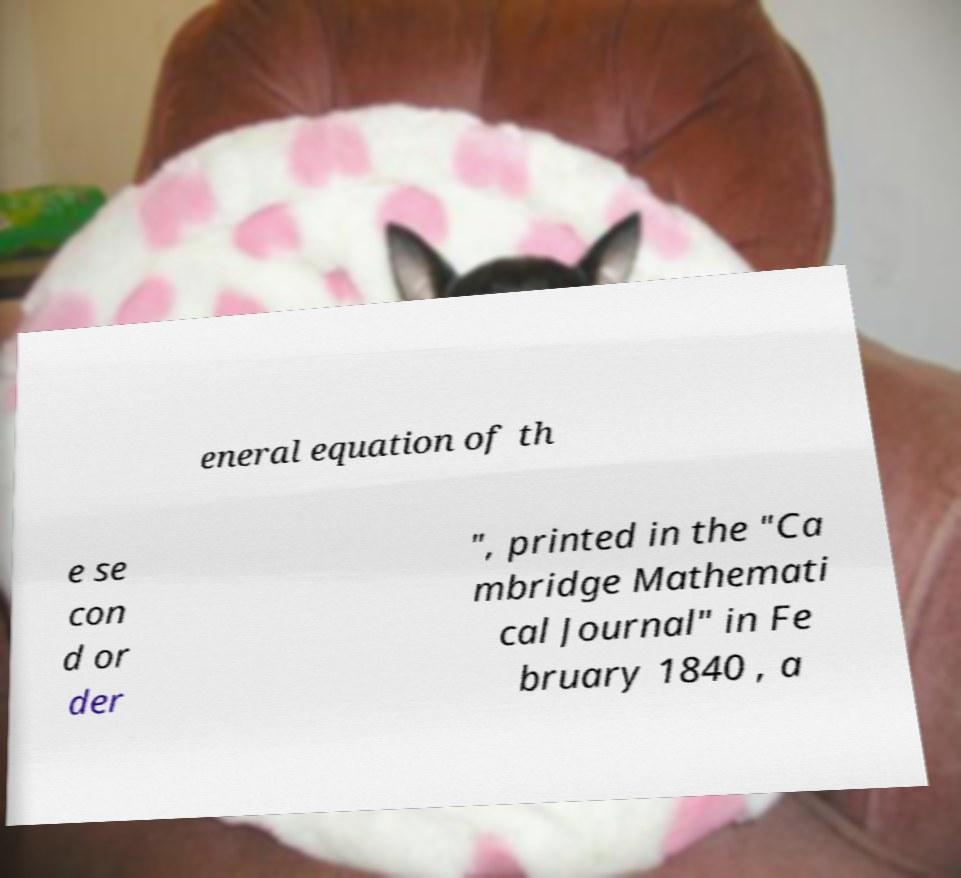Could you assist in decoding the text presented in this image and type it out clearly? eneral equation of th e se con d or der ", printed in the "Ca mbridge Mathemati cal Journal" in Fe bruary 1840 , a 